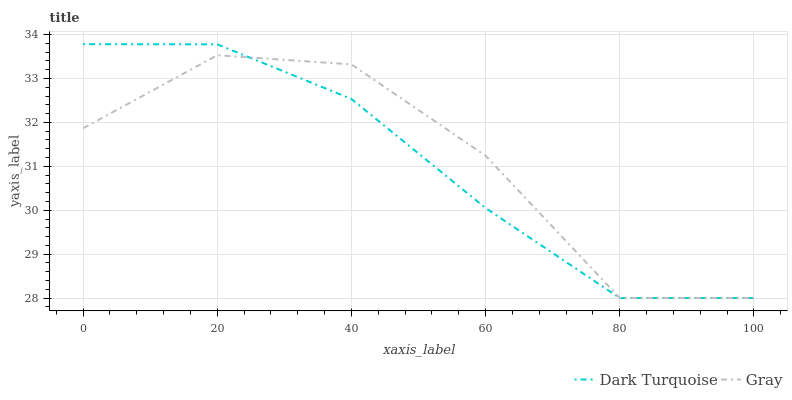Does Gray have the minimum area under the curve?
Answer yes or no. No. Is Gray the smoothest?
Answer yes or no. No. Does Gray have the highest value?
Answer yes or no. No. 